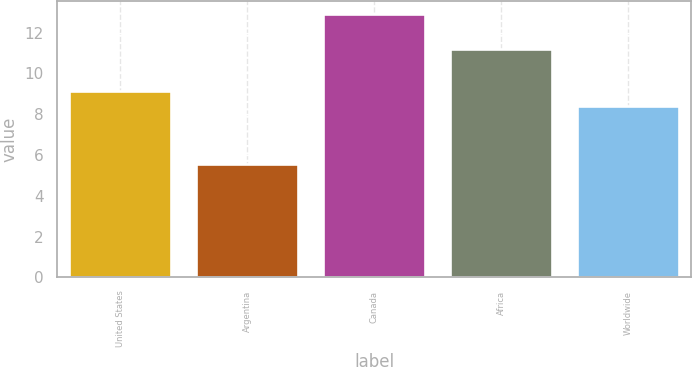Convert chart to OTSL. <chart><loc_0><loc_0><loc_500><loc_500><bar_chart><fcel>United States<fcel>Argentina<fcel>Canada<fcel>Africa<fcel>Worldwide<nl><fcel>9.12<fcel>5.56<fcel>12.93<fcel>11.19<fcel>8.38<nl></chart> 